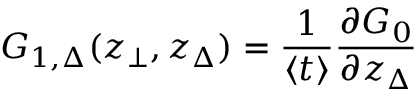Convert formula to latex. <formula><loc_0><loc_0><loc_500><loc_500>G _ { 1 , \Delta } ( z _ { \bot } , z _ { \Delta } ) = \frac { 1 } { \langle t \rangle } \frac { \partial G _ { 0 } } { \partial z _ { \Delta } }</formula> 